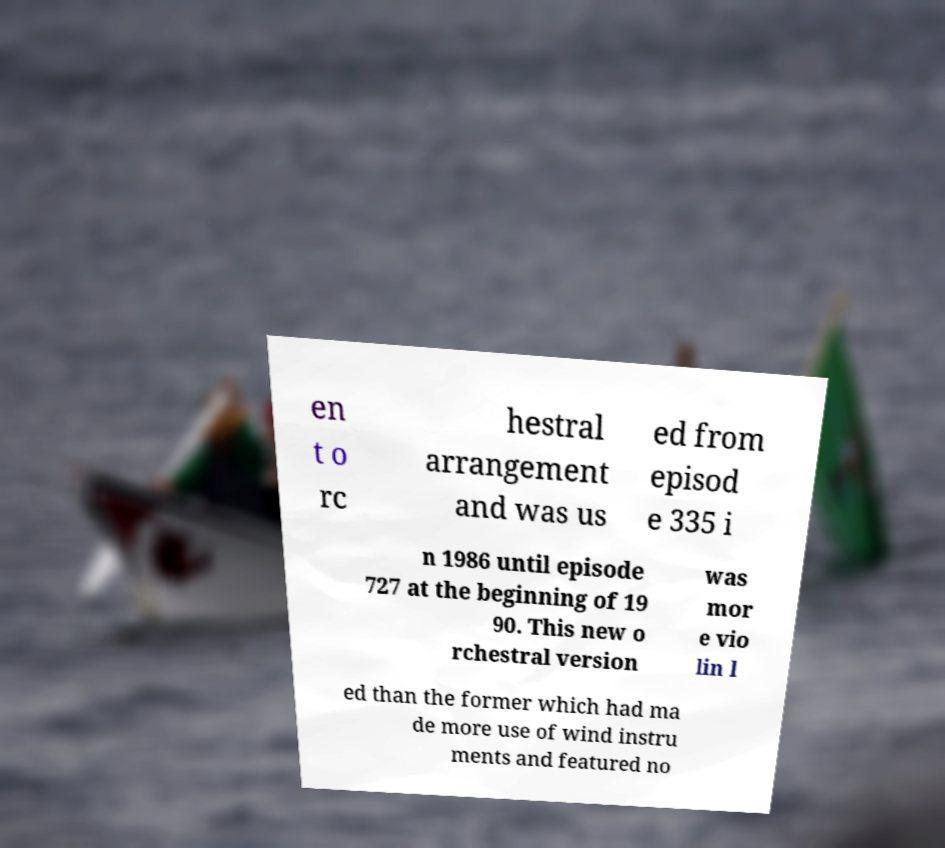Can you accurately transcribe the text from the provided image for me? en t o rc hestral arrangement and was us ed from episod e 335 i n 1986 until episode 727 at the beginning of 19 90. This new o rchestral version was mor e vio lin l ed than the former which had ma de more use of wind instru ments and featured no 